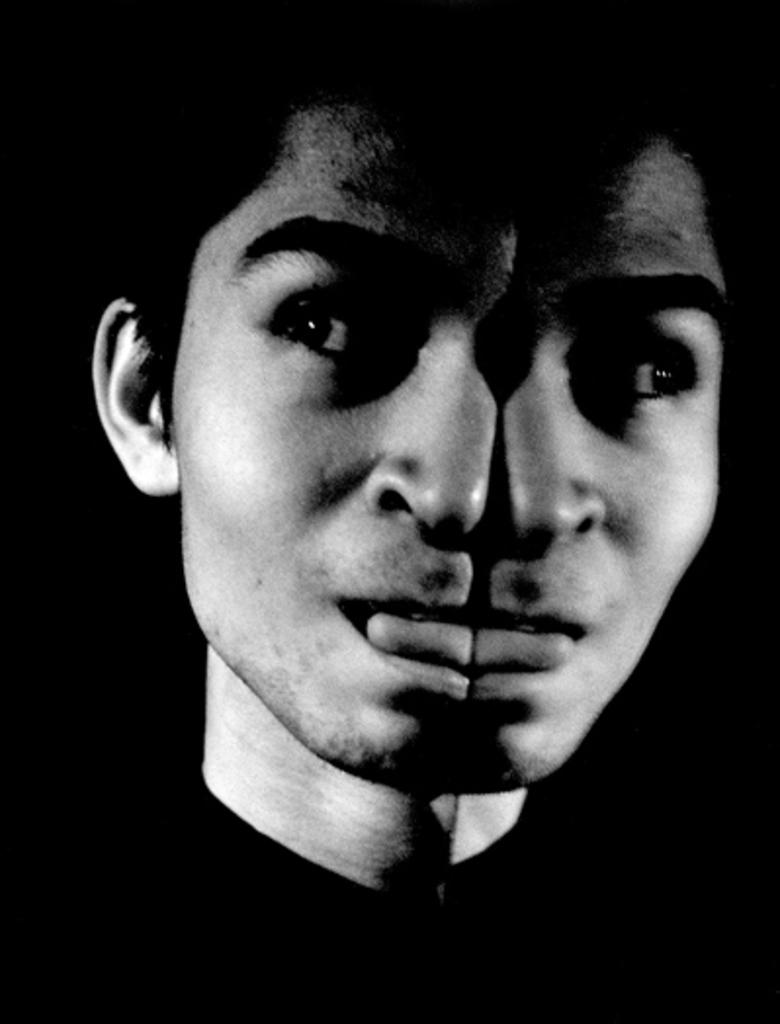What is the color scheme of the image? The image is black and white. Can you describe the main subject of the image? There is a person in the middle of the image. How does the image appear in terms of symmetry? The image appears to be a mirror image. What type of pin can be seen holding the person's clothes together in the image? There is no pin visible in the image, as it is black and white and does not show any clothing details. 